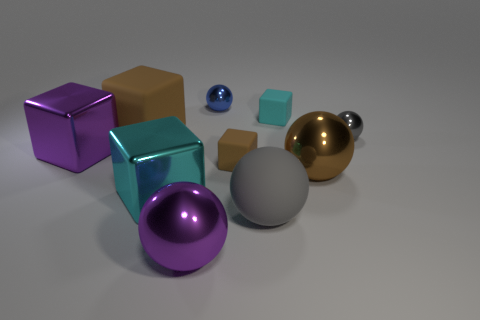Is the number of small blue metal things less than the number of large blue things?
Provide a short and direct response. No. What size is the gray thing behind the brown sphere?
Ensure brevity in your answer.  Small. The thing that is behind the purple cube and on the left side of the blue metallic sphere has what shape?
Provide a short and direct response. Cube. There is a purple object that is the same shape as the gray shiny object; what size is it?
Ensure brevity in your answer.  Large. What number of large brown blocks have the same material as the tiny cyan cube?
Ensure brevity in your answer.  1. Is the color of the large rubber sphere the same as the small shiny ball that is behind the big rubber block?
Your answer should be very brief. No. Is the number of big metal spheres greater than the number of small blue metal cubes?
Make the answer very short. Yes. The large matte block has what color?
Your answer should be compact. Brown. There is a big metallic cube to the right of the purple block; is its color the same as the big rubber sphere?
Your answer should be very brief. No. What material is the small sphere that is the same color as the large rubber ball?
Offer a terse response. Metal. 